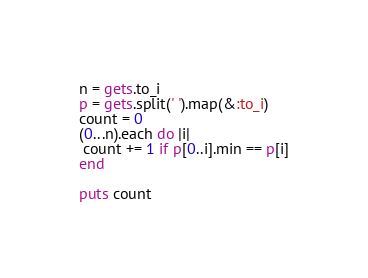Convert code to text. <code><loc_0><loc_0><loc_500><loc_500><_Ruby_>n = gets.to_i
p = gets.split(' ').map(&:to_i)
count = 0
(0...n).each do |i|
 count += 1 if p[0..i].min == p[i]
end

puts count
</code> 